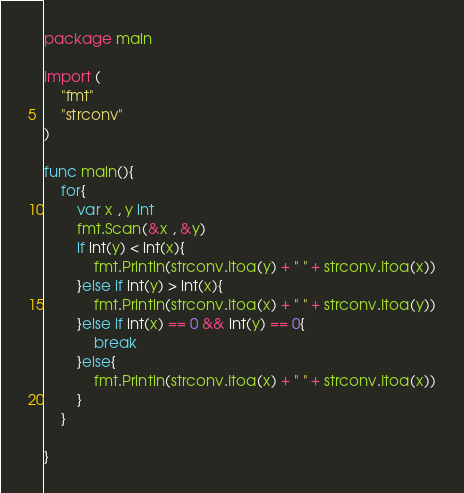Convert code to text. <code><loc_0><loc_0><loc_500><loc_500><_Go_>package main

import (
	"fmt"
	"strconv"
)

func main(){
	for{
		var x , y int
		fmt.Scan(&x , &y)
		if int(y) < int(x){
			fmt.Println(strconv.Itoa(y) + " " + strconv.Itoa(x))
		}else if int(y) > int(x){
			fmt.Println(strconv.Itoa(x) + " " + strconv.Itoa(y))
		}else if int(x) == 0 && int(y) == 0{
			break
		}else{
			fmt.Println(strconv.Itoa(x) + " " + strconv.Itoa(x))
		}
	}

}
</code> 